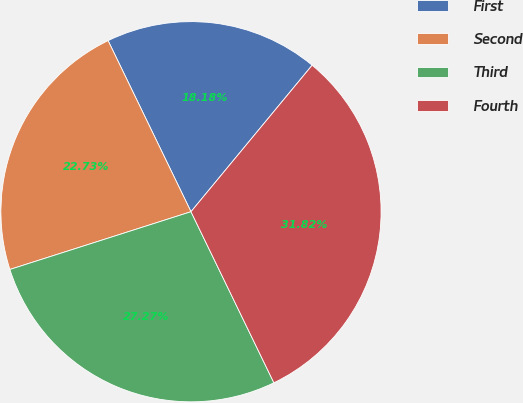Convert chart to OTSL. <chart><loc_0><loc_0><loc_500><loc_500><pie_chart><fcel>First<fcel>Second<fcel>Third<fcel>Fourth<nl><fcel>18.18%<fcel>22.73%<fcel>27.27%<fcel>31.82%<nl></chart> 